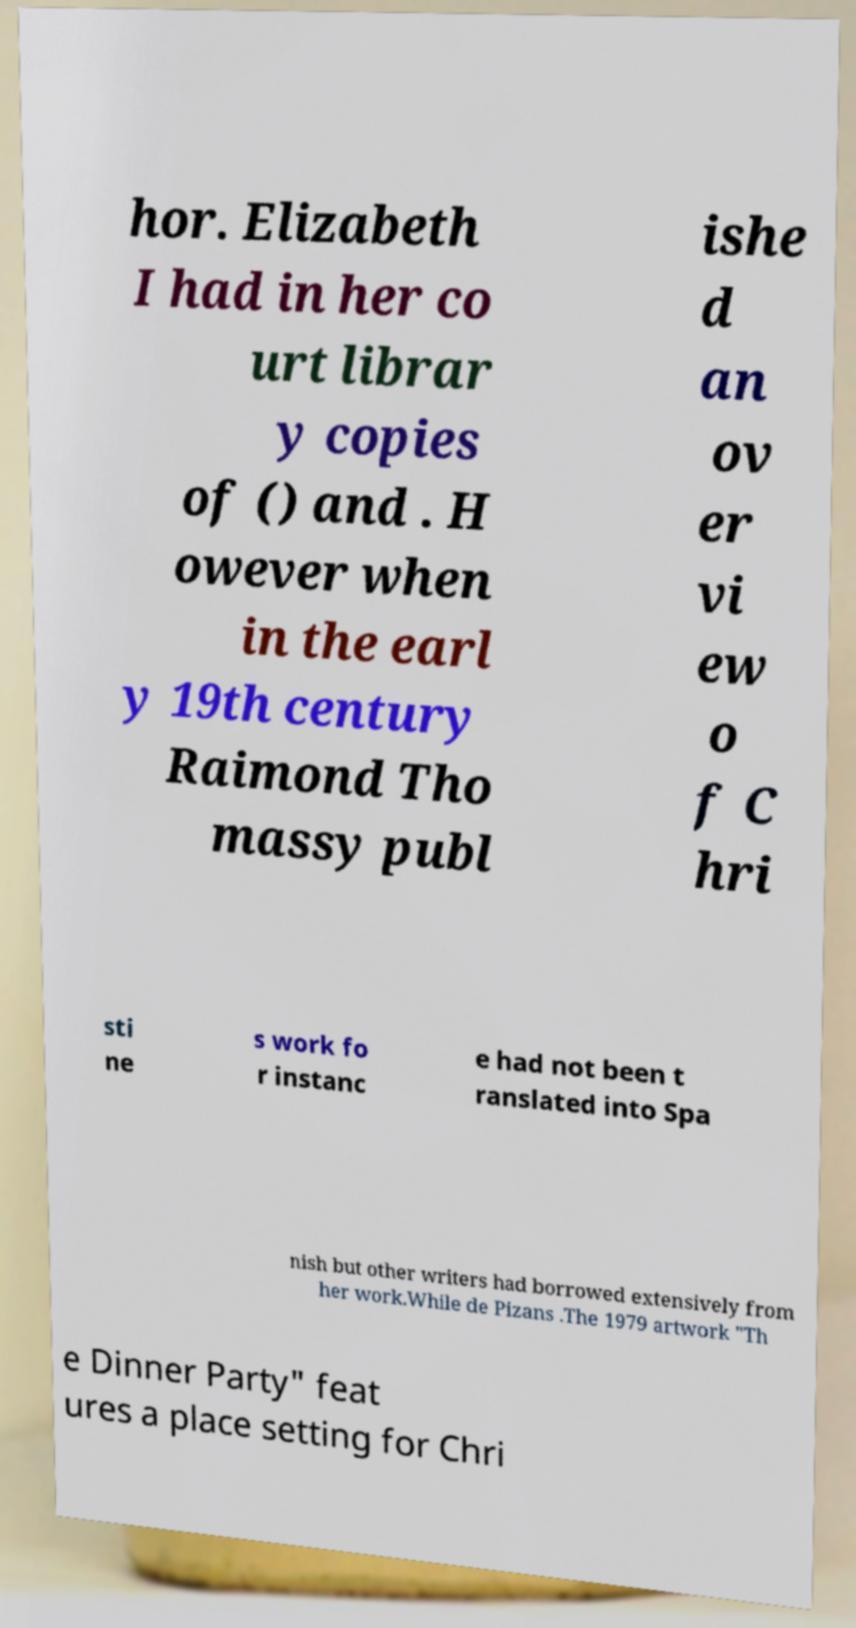Please identify and transcribe the text found in this image. hor. Elizabeth I had in her co urt librar y copies of () and . H owever when in the earl y 19th century Raimond Tho massy publ ishe d an ov er vi ew o f C hri sti ne s work fo r instanc e had not been t ranslated into Spa nish but other writers had borrowed extensively from her work.While de Pizans .The 1979 artwork "Th e Dinner Party" feat ures a place setting for Chri 